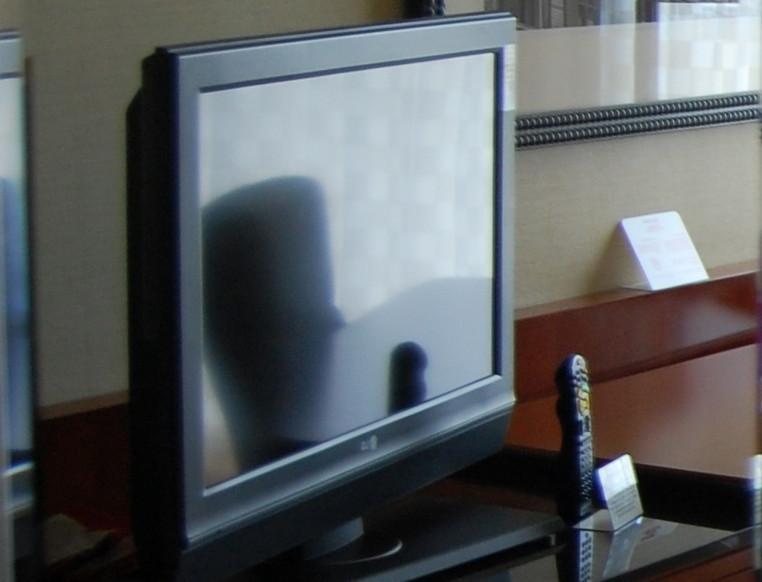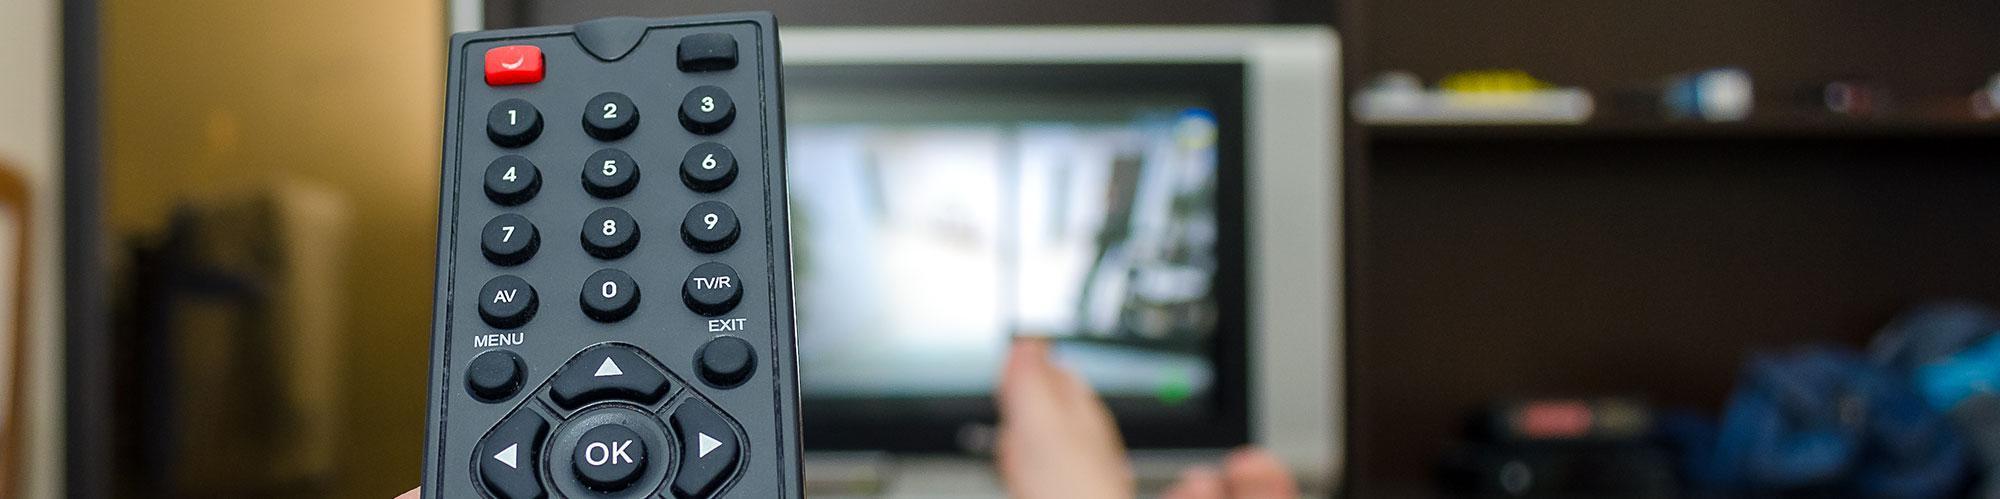The first image is the image on the left, the second image is the image on the right. Analyze the images presented: Is the assertion "There is a yellowish lamp turned on near a wall." valid? Answer yes or no. No. 